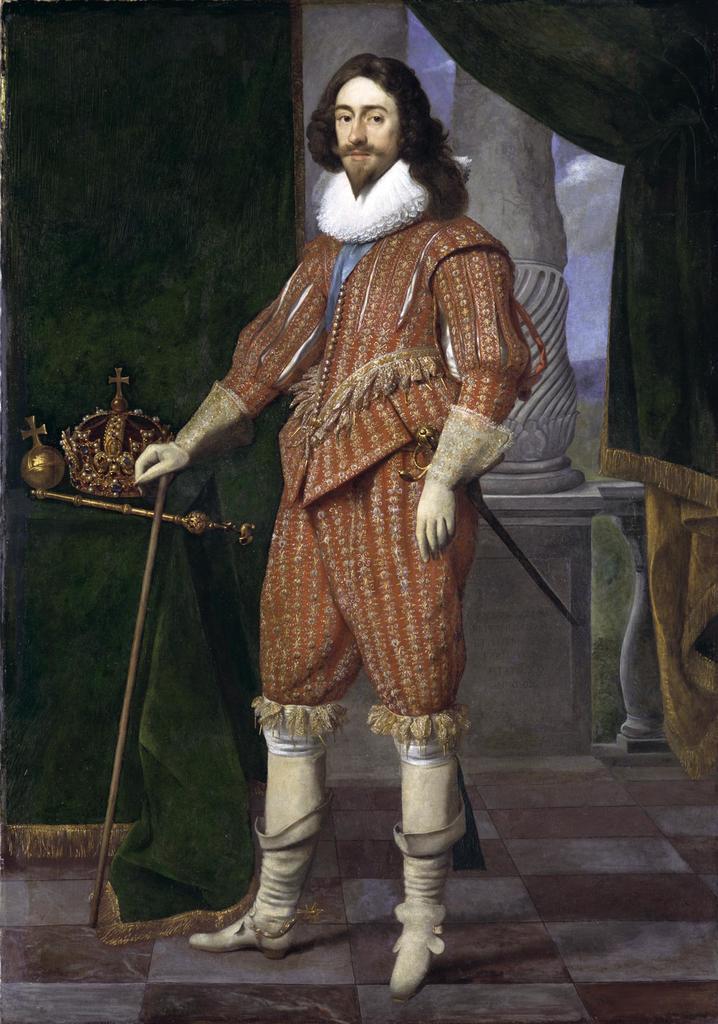Please provide a concise description of this image. In this image we can see a painting of a person. A person is holding an object. There are few curtains in the image. There are few objects in the image. 